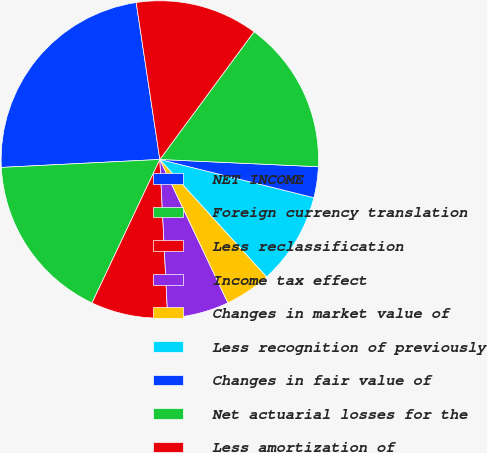Convert chart to OTSL. <chart><loc_0><loc_0><loc_500><loc_500><pie_chart><fcel>NET INCOME<fcel>Foreign currency translation<fcel>Less reclassification<fcel>Income tax effect<fcel>Changes in market value of<fcel>Less recognition of previously<fcel>Changes in fair value of<fcel>Net actuarial losses for the<fcel>Less amortization of<nl><fcel>23.42%<fcel>17.18%<fcel>7.82%<fcel>6.26%<fcel>4.7%<fcel>9.38%<fcel>3.14%<fcel>15.62%<fcel>12.5%<nl></chart> 